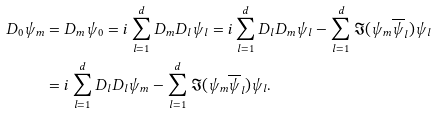Convert formula to latex. <formula><loc_0><loc_0><loc_500><loc_500>D _ { 0 } \psi _ { m } & = D _ { m } \psi _ { 0 } = i \sum _ { l = 1 } ^ { d } D _ { m } D _ { l } \psi _ { l } = i \sum _ { l = 1 } ^ { d } D _ { l } D _ { m } \psi _ { l } - \sum _ { l = 1 } ^ { d } \Im ( \psi _ { m } \overline { \psi } _ { l } ) \psi _ { l } \\ & = i \sum _ { l = 1 } ^ { d } D _ { l } D _ { l } \psi _ { m } - \sum _ { l = 1 } ^ { d } \Im ( \psi _ { m } \overline { \psi } _ { l } ) \psi _ { l } .</formula> 